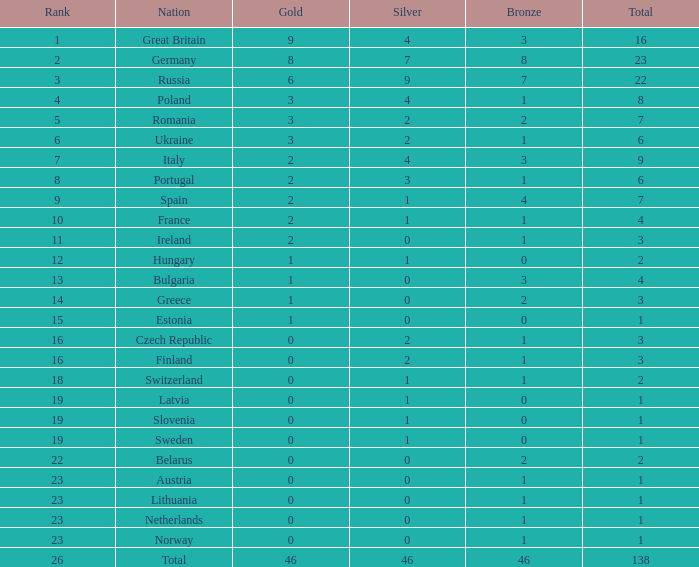What is the total number for a total when the nation is netherlands and silver is larger than 0? 0.0. 